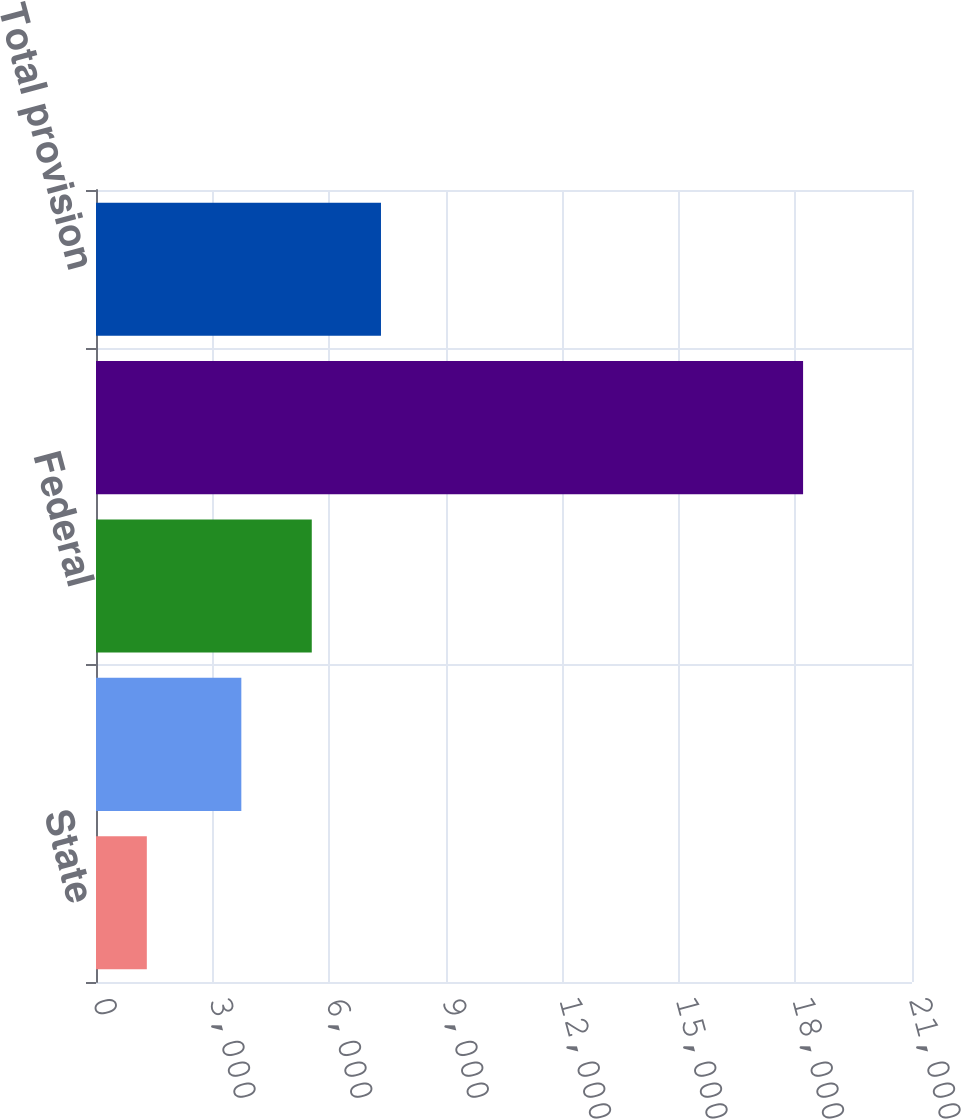<chart> <loc_0><loc_0><loc_500><loc_500><bar_chart><fcel>State<fcel>Foreign<fcel>Federal<fcel>(Decrease) increase in<fcel>Total provision<nl><fcel>1308<fcel>3740<fcel>5553<fcel>18197<fcel>7334<nl></chart> 